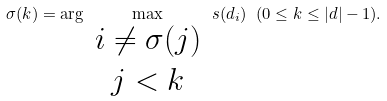Convert formula to latex. <formula><loc_0><loc_0><loc_500><loc_500>\sigma ( k ) = \arg \max _ { { \begin{array} { c } i \neq \sigma ( j ) \\ j < k \end{array} } } s ( d _ { i } ) \ ( 0 \leq k \leq | d | - 1 ) .</formula> 